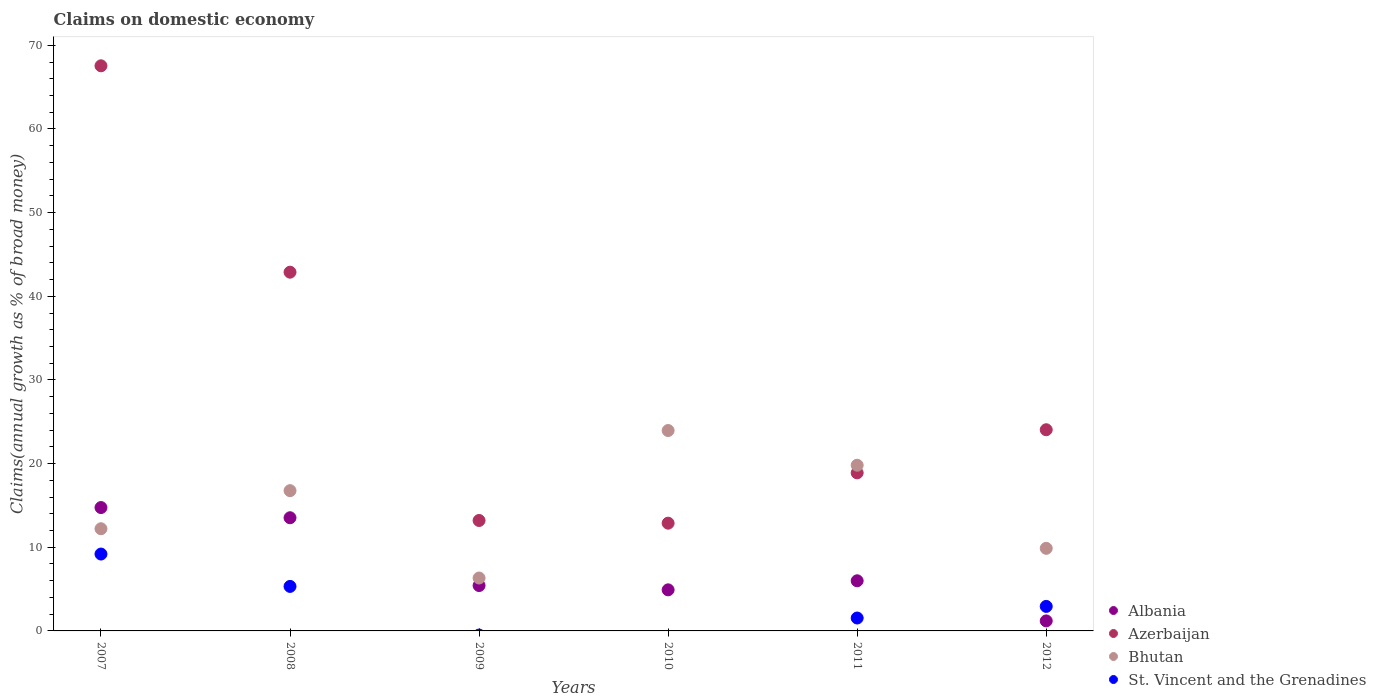How many different coloured dotlines are there?
Your response must be concise. 4. What is the percentage of broad money claimed on domestic economy in Azerbaijan in 2011?
Offer a terse response. 18.89. Across all years, what is the maximum percentage of broad money claimed on domestic economy in Albania?
Your answer should be compact. 14.75. Across all years, what is the minimum percentage of broad money claimed on domestic economy in Albania?
Ensure brevity in your answer.  1.2. What is the total percentage of broad money claimed on domestic economy in Bhutan in the graph?
Offer a terse response. 88.93. What is the difference between the percentage of broad money claimed on domestic economy in St. Vincent and the Grenadines in 2011 and that in 2012?
Offer a very short reply. -1.39. What is the difference between the percentage of broad money claimed on domestic economy in Albania in 2011 and the percentage of broad money claimed on domestic economy in Bhutan in 2009?
Your answer should be very brief. -0.33. What is the average percentage of broad money claimed on domestic economy in St. Vincent and the Grenadines per year?
Keep it short and to the point. 3.16. In the year 2011, what is the difference between the percentage of broad money claimed on domestic economy in St. Vincent and the Grenadines and percentage of broad money claimed on domestic economy in Albania?
Provide a succinct answer. -4.45. What is the ratio of the percentage of broad money claimed on domestic economy in Azerbaijan in 2007 to that in 2008?
Offer a very short reply. 1.58. What is the difference between the highest and the second highest percentage of broad money claimed on domestic economy in Albania?
Provide a short and direct response. 1.22. What is the difference between the highest and the lowest percentage of broad money claimed on domestic economy in St. Vincent and the Grenadines?
Ensure brevity in your answer.  9.19. Is the sum of the percentage of broad money claimed on domestic economy in Bhutan in 2010 and 2011 greater than the maximum percentage of broad money claimed on domestic economy in Azerbaijan across all years?
Ensure brevity in your answer.  No. Is it the case that in every year, the sum of the percentage of broad money claimed on domestic economy in St. Vincent and the Grenadines and percentage of broad money claimed on domestic economy in Azerbaijan  is greater than the percentage of broad money claimed on domestic economy in Bhutan?
Provide a succinct answer. No. Does the percentage of broad money claimed on domestic economy in St. Vincent and the Grenadines monotonically increase over the years?
Provide a short and direct response. No. Is the percentage of broad money claimed on domestic economy in Azerbaijan strictly less than the percentage of broad money claimed on domestic economy in St. Vincent and the Grenadines over the years?
Offer a terse response. No. How many dotlines are there?
Your answer should be compact. 4. How many years are there in the graph?
Keep it short and to the point. 6. What is the difference between two consecutive major ticks on the Y-axis?
Give a very brief answer. 10. Are the values on the major ticks of Y-axis written in scientific E-notation?
Provide a short and direct response. No. What is the title of the graph?
Your response must be concise. Claims on domestic economy. What is the label or title of the Y-axis?
Your answer should be very brief. Claims(annual growth as % of broad money). What is the Claims(annual growth as % of broad money) in Albania in 2007?
Provide a succinct answer. 14.75. What is the Claims(annual growth as % of broad money) in Azerbaijan in 2007?
Your answer should be compact. 67.55. What is the Claims(annual growth as % of broad money) of Bhutan in 2007?
Give a very brief answer. 12.21. What is the Claims(annual growth as % of broad money) of St. Vincent and the Grenadines in 2007?
Offer a very short reply. 9.19. What is the Claims(annual growth as % of broad money) in Albania in 2008?
Offer a terse response. 13.53. What is the Claims(annual growth as % of broad money) in Azerbaijan in 2008?
Your answer should be very brief. 42.88. What is the Claims(annual growth as % of broad money) of Bhutan in 2008?
Ensure brevity in your answer.  16.77. What is the Claims(annual growth as % of broad money) in St. Vincent and the Grenadines in 2008?
Give a very brief answer. 5.32. What is the Claims(annual growth as % of broad money) of Albania in 2009?
Your answer should be compact. 5.42. What is the Claims(annual growth as % of broad money) in Azerbaijan in 2009?
Provide a short and direct response. 13.2. What is the Claims(annual growth as % of broad money) of Bhutan in 2009?
Give a very brief answer. 6.32. What is the Claims(annual growth as % of broad money) of St. Vincent and the Grenadines in 2009?
Ensure brevity in your answer.  0. What is the Claims(annual growth as % of broad money) of Albania in 2010?
Provide a short and direct response. 4.91. What is the Claims(annual growth as % of broad money) in Azerbaijan in 2010?
Your answer should be very brief. 12.88. What is the Claims(annual growth as % of broad money) of Bhutan in 2010?
Give a very brief answer. 23.95. What is the Claims(annual growth as % of broad money) in St. Vincent and the Grenadines in 2010?
Give a very brief answer. 0. What is the Claims(annual growth as % of broad money) in Albania in 2011?
Make the answer very short. 5.99. What is the Claims(annual growth as % of broad money) of Azerbaijan in 2011?
Your answer should be very brief. 18.89. What is the Claims(annual growth as % of broad money) of Bhutan in 2011?
Offer a very short reply. 19.81. What is the Claims(annual growth as % of broad money) of St. Vincent and the Grenadines in 2011?
Provide a short and direct response. 1.54. What is the Claims(annual growth as % of broad money) of Albania in 2012?
Your response must be concise. 1.2. What is the Claims(annual growth as % of broad money) in Azerbaijan in 2012?
Offer a terse response. 24.05. What is the Claims(annual growth as % of broad money) in Bhutan in 2012?
Your answer should be very brief. 9.87. What is the Claims(annual growth as % of broad money) of St. Vincent and the Grenadines in 2012?
Make the answer very short. 2.93. Across all years, what is the maximum Claims(annual growth as % of broad money) of Albania?
Offer a terse response. 14.75. Across all years, what is the maximum Claims(annual growth as % of broad money) of Azerbaijan?
Provide a short and direct response. 67.55. Across all years, what is the maximum Claims(annual growth as % of broad money) of Bhutan?
Keep it short and to the point. 23.95. Across all years, what is the maximum Claims(annual growth as % of broad money) of St. Vincent and the Grenadines?
Give a very brief answer. 9.19. Across all years, what is the minimum Claims(annual growth as % of broad money) of Albania?
Offer a very short reply. 1.2. Across all years, what is the minimum Claims(annual growth as % of broad money) in Azerbaijan?
Offer a terse response. 12.88. Across all years, what is the minimum Claims(annual growth as % of broad money) of Bhutan?
Keep it short and to the point. 6.32. What is the total Claims(annual growth as % of broad money) of Albania in the graph?
Offer a very short reply. 45.8. What is the total Claims(annual growth as % of broad money) in Azerbaijan in the graph?
Offer a very short reply. 179.45. What is the total Claims(annual growth as % of broad money) of Bhutan in the graph?
Provide a succinct answer. 88.93. What is the total Claims(annual growth as % of broad money) in St. Vincent and the Grenadines in the graph?
Provide a succinct answer. 18.98. What is the difference between the Claims(annual growth as % of broad money) of Albania in 2007 and that in 2008?
Give a very brief answer. 1.22. What is the difference between the Claims(annual growth as % of broad money) in Azerbaijan in 2007 and that in 2008?
Offer a terse response. 24.67. What is the difference between the Claims(annual growth as % of broad money) in Bhutan in 2007 and that in 2008?
Keep it short and to the point. -4.55. What is the difference between the Claims(annual growth as % of broad money) of St. Vincent and the Grenadines in 2007 and that in 2008?
Provide a succinct answer. 3.87. What is the difference between the Claims(annual growth as % of broad money) in Albania in 2007 and that in 2009?
Give a very brief answer. 9.32. What is the difference between the Claims(annual growth as % of broad money) in Azerbaijan in 2007 and that in 2009?
Provide a succinct answer. 54.35. What is the difference between the Claims(annual growth as % of broad money) of Bhutan in 2007 and that in 2009?
Offer a very short reply. 5.89. What is the difference between the Claims(annual growth as % of broad money) of Albania in 2007 and that in 2010?
Ensure brevity in your answer.  9.84. What is the difference between the Claims(annual growth as % of broad money) of Azerbaijan in 2007 and that in 2010?
Make the answer very short. 54.67. What is the difference between the Claims(annual growth as % of broad money) in Bhutan in 2007 and that in 2010?
Your response must be concise. -11.74. What is the difference between the Claims(annual growth as % of broad money) of Albania in 2007 and that in 2011?
Ensure brevity in your answer.  8.75. What is the difference between the Claims(annual growth as % of broad money) in Azerbaijan in 2007 and that in 2011?
Provide a short and direct response. 48.66. What is the difference between the Claims(annual growth as % of broad money) in Bhutan in 2007 and that in 2011?
Make the answer very short. -7.59. What is the difference between the Claims(annual growth as % of broad money) in St. Vincent and the Grenadines in 2007 and that in 2011?
Offer a very short reply. 7.65. What is the difference between the Claims(annual growth as % of broad money) of Albania in 2007 and that in 2012?
Offer a very short reply. 13.55. What is the difference between the Claims(annual growth as % of broad money) of Azerbaijan in 2007 and that in 2012?
Give a very brief answer. 43.5. What is the difference between the Claims(annual growth as % of broad money) in Bhutan in 2007 and that in 2012?
Ensure brevity in your answer.  2.34. What is the difference between the Claims(annual growth as % of broad money) of St. Vincent and the Grenadines in 2007 and that in 2012?
Your response must be concise. 6.26. What is the difference between the Claims(annual growth as % of broad money) in Albania in 2008 and that in 2009?
Your answer should be very brief. 8.1. What is the difference between the Claims(annual growth as % of broad money) of Azerbaijan in 2008 and that in 2009?
Your answer should be compact. 29.68. What is the difference between the Claims(annual growth as % of broad money) in Bhutan in 2008 and that in 2009?
Keep it short and to the point. 10.44. What is the difference between the Claims(annual growth as % of broad money) in Albania in 2008 and that in 2010?
Offer a very short reply. 8.62. What is the difference between the Claims(annual growth as % of broad money) of Azerbaijan in 2008 and that in 2010?
Offer a very short reply. 30. What is the difference between the Claims(annual growth as % of broad money) of Bhutan in 2008 and that in 2010?
Give a very brief answer. -7.19. What is the difference between the Claims(annual growth as % of broad money) of Albania in 2008 and that in 2011?
Ensure brevity in your answer.  7.54. What is the difference between the Claims(annual growth as % of broad money) in Azerbaijan in 2008 and that in 2011?
Give a very brief answer. 23.99. What is the difference between the Claims(annual growth as % of broad money) of Bhutan in 2008 and that in 2011?
Your answer should be very brief. -3.04. What is the difference between the Claims(annual growth as % of broad money) of St. Vincent and the Grenadines in 2008 and that in 2011?
Keep it short and to the point. 3.78. What is the difference between the Claims(annual growth as % of broad money) of Albania in 2008 and that in 2012?
Offer a very short reply. 12.33. What is the difference between the Claims(annual growth as % of broad money) in Azerbaijan in 2008 and that in 2012?
Give a very brief answer. 18.83. What is the difference between the Claims(annual growth as % of broad money) of Bhutan in 2008 and that in 2012?
Provide a short and direct response. 6.89. What is the difference between the Claims(annual growth as % of broad money) in St. Vincent and the Grenadines in 2008 and that in 2012?
Provide a short and direct response. 2.39. What is the difference between the Claims(annual growth as % of broad money) of Albania in 2009 and that in 2010?
Your answer should be very brief. 0.51. What is the difference between the Claims(annual growth as % of broad money) in Azerbaijan in 2009 and that in 2010?
Provide a succinct answer. 0.32. What is the difference between the Claims(annual growth as % of broad money) in Bhutan in 2009 and that in 2010?
Make the answer very short. -17.63. What is the difference between the Claims(annual growth as % of broad money) of Albania in 2009 and that in 2011?
Make the answer very short. -0.57. What is the difference between the Claims(annual growth as % of broad money) of Azerbaijan in 2009 and that in 2011?
Give a very brief answer. -5.69. What is the difference between the Claims(annual growth as % of broad money) in Bhutan in 2009 and that in 2011?
Your response must be concise. -13.48. What is the difference between the Claims(annual growth as % of broad money) of Albania in 2009 and that in 2012?
Give a very brief answer. 4.23. What is the difference between the Claims(annual growth as % of broad money) of Azerbaijan in 2009 and that in 2012?
Your answer should be very brief. -10.85. What is the difference between the Claims(annual growth as % of broad money) in Bhutan in 2009 and that in 2012?
Your response must be concise. -3.55. What is the difference between the Claims(annual growth as % of broad money) in Albania in 2010 and that in 2011?
Provide a short and direct response. -1.08. What is the difference between the Claims(annual growth as % of broad money) in Azerbaijan in 2010 and that in 2011?
Your answer should be compact. -6.01. What is the difference between the Claims(annual growth as % of broad money) in Bhutan in 2010 and that in 2011?
Provide a succinct answer. 4.15. What is the difference between the Claims(annual growth as % of broad money) in Albania in 2010 and that in 2012?
Give a very brief answer. 3.71. What is the difference between the Claims(annual growth as % of broad money) of Azerbaijan in 2010 and that in 2012?
Make the answer very short. -11.17. What is the difference between the Claims(annual growth as % of broad money) in Bhutan in 2010 and that in 2012?
Keep it short and to the point. 14.08. What is the difference between the Claims(annual growth as % of broad money) of Albania in 2011 and that in 2012?
Provide a short and direct response. 4.79. What is the difference between the Claims(annual growth as % of broad money) in Azerbaijan in 2011 and that in 2012?
Make the answer very short. -5.16. What is the difference between the Claims(annual growth as % of broad money) of Bhutan in 2011 and that in 2012?
Provide a succinct answer. 9.93. What is the difference between the Claims(annual growth as % of broad money) in St. Vincent and the Grenadines in 2011 and that in 2012?
Offer a terse response. -1.39. What is the difference between the Claims(annual growth as % of broad money) in Albania in 2007 and the Claims(annual growth as % of broad money) in Azerbaijan in 2008?
Your answer should be compact. -28.13. What is the difference between the Claims(annual growth as % of broad money) of Albania in 2007 and the Claims(annual growth as % of broad money) of Bhutan in 2008?
Provide a short and direct response. -2.02. What is the difference between the Claims(annual growth as % of broad money) in Albania in 2007 and the Claims(annual growth as % of broad money) in St. Vincent and the Grenadines in 2008?
Provide a short and direct response. 9.43. What is the difference between the Claims(annual growth as % of broad money) of Azerbaijan in 2007 and the Claims(annual growth as % of broad money) of Bhutan in 2008?
Provide a succinct answer. 50.78. What is the difference between the Claims(annual growth as % of broad money) of Azerbaijan in 2007 and the Claims(annual growth as % of broad money) of St. Vincent and the Grenadines in 2008?
Your response must be concise. 62.23. What is the difference between the Claims(annual growth as % of broad money) in Bhutan in 2007 and the Claims(annual growth as % of broad money) in St. Vincent and the Grenadines in 2008?
Ensure brevity in your answer.  6.89. What is the difference between the Claims(annual growth as % of broad money) in Albania in 2007 and the Claims(annual growth as % of broad money) in Azerbaijan in 2009?
Give a very brief answer. 1.55. What is the difference between the Claims(annual growth as % of broad money) of Albania in 2007 and the Claims(annual growth as % of broad money) of Bhutan in 2009?
Your response must be concise. 8.42. What is the difference between the Claims(annual growth as % of broad money) in Azerbaijan in 2007 and the Claims(annual growth as % of broad money) in Bhutan in 2009?
Give a very brief answer. 61.23. What is the difference between the Claims(annual growth as % of broad money) in Albania in 2007 and the Claims(annual growth as % of broad money) in Azerbaijan in 2010?
Your answer should be very brief. 1.87. What is the difference between the Claims(annual growth as % of broad money) of Albania in 2007 and the Claims(annual growth as % of broad money) of Bhutan in 2010?
Give a very brief answer. -9.21. What is the difference between the Claims(annual growth as % of broad money) of Azerbaijan in 2007 and the Claims(annual growth as % of broad money) of Bhutan in 2010?
Offer a very short reply. 43.6. What is the difference between the Claims(annual growth as % of broad money) of Albania in 2007 and the Claims(annual growth as % of broad money) of Azerbaijan in 2011?
Offer a very short reply. -4.15. What is the difference between the Claims(annual growth as % of broad money) of Albania in 2007 and the Claims(annual growth as % of broad money) of Bhutan in 2011?
Your response must be concise. -5.06. What is the difference between the Claims(annual growth as % of broad money) in Albania in 2007 and the Claims(annual growth as % of broad money) in St. Vincent and the Grenadines in 2011?
Offer a very short reply. 13.2. What is the difference between the Claims(annual growth as % of broad money) of Azerbaijan in 2007 and the Claims(annual growth as % of broad money) of Bhutan in 2011?
Offer a very short reply. 47.74. What is the difference between the Claims(annual growth as % of broad money) in Azerbaijan in 2007 and the Claims(annual growth as % of broad money) in St. Vincent and the Grenadines in 2011?
Your answer should be very brief. 66.01. What is the difference between the Claims(annual growth as % of broad money) of Bhutan in 2007 and the Claims(annual growth as % of broad money) of St. Vincent and the Grenadines in 2011?
Your response must be concise. 10.67. What is the difference between the Claims(annual growth as % of broad money) in Albania in 2007 and the Claims(annual growth as % of broad money) in Azerbaijan in 2012?
Make the answer very short. -9.3. What is the difference between the Claims(annual growth as % of broad money) in Albania in 2007 and the Claims(annual growth as % of broad money) in Bhutan in 2012?
Your response must be concise. 4.87. What is the difference between the Claims(annual growth as % of broad money) of Albania in 2007 and the Claims(annual growth as % of broad money) of St. Vincent and the Grenadines in 2012?
Ensure brevity in your answer.  11.82. What is the difference between the Claims(annual growth as % of broad money) of Azerbaijan in 2007 and the Claims(annual growth as % of broad money) of Bhutan in 2012?
Make the answer very short. 57.68. What is the difference between the Claims(annual growth as % of broad money) of Azerbaijan in 2007 and the Claims(annual growth as % of broad money) of St. Vincent and the Grenadines in 2012?
Ensure brevity in your answer.  64.62. What is the difference between the Claims(annual growth as % of broad money) of Bhutan in 2007 and the Claims(annual growth as % of broad money) of St. Vincent and the Grenadines in 2012?
Keep it short and to the point. 9.28. What is the difference between the Claims(annual growth as % of broad money) in Albania in 2008 and the Claims(annual growth as % of broad money) in Azerbaijan in 2009?
Your answer should be compact. 0.33. What is the difference between the Claims(annual growth as % of broad money) of Albania in 2008 and the Claims(annual growth as % of broad money) of Bhutan in 2009?
Offer a very short reply. 7.2. What is the difference between the Claims(annual growth as % of broad money) of Azerbaijan in 2008 and the Claims(annual growth as % of broad money) of Bhutan in 2009?
Your response must be concise. 36.56. What is the difference between the Claims(annual growth as % of broad money) of Albania in 2008 and the Claims(annual growth as % of broad money) of Azerbaijan in 2010?
Make the answer very short. 0.65. What is the difference between the Claims(annual growth as % of broad money) in Albania in 2008 and the Claims(annual growth as % of broad money) in Bhutan in 2010?
Provide a succinct answer. -10.43. What is the difference between the Claims(annual growth as % of broad money) of Azerbaijan in 2008 and the Claims(annual growth as % of broad money) of Bhutan in 2010?
Your answer should be very brief. 18.93. What is the difference between the Claims(annual growth as % of broad money) in Albania in 2008 and the Claims(annual growth as % of broad money) in Azerbaijan in 2011?
Provide a short and direct response. -5.36. What is the difference between the Claims(annual growth as % of broad money) of Albania in 2008 and the Claims(annual growth as % of broad money) of Bhutan in 2011?
Offer a terse response. -6.28. What is the difference between the Claims(annual growth as % of broad money) of Albania in 2008 and the Claims(annual growth as % of broad money) of St. Vincent and the Grenadines in 2011?
Give a very brief answer. 11.99. What is the difference between the Claims(annual growth as % of broad money) of Azerbaijan in 2008 and the Claims(annual growth as % of broad money) of Bhutan in 2011?
Your answer should be very brief. 23.08. What is the difference between the Claims(annual growth as % of broad money) in Azerbaijan in 2008 and the Claims(annual growth as % of broad money) in St. Vincent and the Grenadines in 2011?
Your answer should be compact. 41.34. What is the difference between the Claims(annual growth as % of broad money) of Bhutan in 2008 and the Claims(annual growth as % of broad money) of St. Vincent and the Grenadines in 2011?
Your answer should be very brief. 15.22. What is the difference between the Claims(annual growth as % of broad money) of Albania in 2008 and the Claims(annual growth as % of broad money) of Azerbaijan in 2012?
Provide a short and direct response. -10.52. What is the difference between the Claims(annual growth as % of broad money) in Albania in 2008 and the Claims(annual growth as % of broad money) in Bhutan in 2012?
Provide a short and direct response. 3.66. What is the difference between the Claims(annual growth as % of broad money) in Albania in 2008 and the Claims(annual growth as % of broad money) in St. Vincent and the Grenadines in 2012?
Your answer should be very brief. 10.6. What is the difference between the Claims(annual growth as % of broad money) of Azerbaijan in 2008 and the Claims(annual growth as % of broad money) of Bhutan in 2012?
Provide a short and direct response. 33.01. What is the difference between the Claims(annual growth as % of broad money) of Azerbaijan in 2008 and the Claims(annual growth as % of broad money) of St. Vincent and the Grenadines in 2012?
Ensure brevity in your answer.  39.95. What is the difference between the Claims(annual growth as % of broad money) of Bhutan in 2008 and the Claims(annual growth as % of broad money) of St. Vincent and the Grenadines in 2012?
Offer a terse response. 13.84. What is the difference between the Claims(annual growth as % of broad money) of Albania in 2009 and the Claims(annual growth as % of broad money) of Azerbaijan in 2010?
Make the answer very short. -7.46. What is the difference between the Claims(annual growth as % of broad money) in Albania in 2009 and the Claims(annual growth as % of broad money) in Bhutan in 2010?
Ensure brevity in your answer.  -18.53. What is the difference between the Claims(annual growth as % of broad money) of Azerbaijan in 2009 and the Claims(annual growth as % of broad money) of Bhutan in 2010?
Make the answer very short. -10.75. What is the difference between the Claims(annual growth as % of broad money) of Albania in 2009 and the Claims(annual growth as % of broad money) of Azerbaijan in 2011?
Keep it short and to the point. -13.47. What is the difference between the Claims(annual growth as % of broad money) in Albania in 2009 and the Claims(annual growth as % of broad money) in Bhutan in 2011?
Provide a short and direct response. -14.38. What is the difference between the Claims(annual growth as % of broad money) in Albania in 2009 and the Claims(annual growth as % of broad money) in St. Vincent and the Grenadines in 2011?
Make the answer very short. 3.88. What is the difference between the Claims(annual growth as % of broad money) in Azerbaijan in 2009 and the Claims(annual growth as % of broad money) in Bhutan in 2011?
Offer a terse response. -6.61. What is the difference between the Claims(annual growth as % of broad money) in Azerbaijan in 2009 and the Claims(annual growth as % of broad money) in St. Vincent and the Grenadines in 2011?
Give a very brief answer. 11.66. What is the difference between the Claims(annual growth as % of broad money) of Bhutan in 2009 and the Claims(annual growth as % of broad money) of St. Vincent and the Grenadines in 2011?
Provide a short and direct response. 4.78. What is the difference between the Claims(annual growth as % of broad money) of Albania in 2009 and the Claims(annual growth as % of broad money) of Azerbaijan in 2012?
Provide a short and direct response. -18.62. What is the difference between the Claims(annual growth as % of broad money) in Albania in 2009 and the Claims(annual growth as % of broad money) in Bhutan in 2012?
Offer a very short reply. -4.45. What is the difference between the Claims(annual growth as % of broad money) in Albania in 2009 and the Claims(annual growth as % of broad money) in St. Vincent and the Grenadines in 2012?
Make the answer very short. 2.49. What is the difference between the Claims(annual growth as % of broad money) of Azerbaijan in 2009 and the Claims(annual growth as % of broad money) of Bhutan in 2012?
Your answer should be very brief. 3.33. What is the difference between the Claims(annual growth as % of broad money) in Azerbaijan in 2009 and the Claims(annual growth as % of broad money) in St. Vincent and the Grenadines in 2012?
Make the answer very short. 10.27. What is the difference between the Claims(annual growth as % of broad money) in Bhutan in 2009 and the Claims(annual growth as % of broad money) in St. Vincent and the Grenadines in 2012?
Give a very brief answer. 3.39. What is the difference between the Claims(annual growth as % of broad money) of Albania in 2010 and the Claims(annual growth as % of broad money) of Azerbaijan in 2011?
Offer a terse response. -13.98. What is the difference between the Claims(annual growth as % of broad money) in Albania in 2010 and the Claims(annual growth as % of broad money) in Bhutan in 2011?
Offer a very short reply. -14.89. What is the difference between the Claims(annual growth as % of broad money) in Albania in 2010 and the Claims(annual growth as % of broad money) in St. Vincent and the Grenadines in 2011?
Provide a short and direct response. 3.37. What is the difference between the Claims(annual growth as % of broad money) of Azerbaijan in 2010 and the Claims(annual growth as % of broad money) of Bhutan in 2011?
Provide a succinct answer. -6.93. What is the difference between the Claims(annual growth as % of broad money) of Azerbaijan in 2010 and the Claims(annual growth as % of broad money) of St. Vincent and the Grenadines in 2011?
Keep it short and to the point. 11.34. What is the difference between the Claims(annual growth as % of broad money) in Bhutan in 2010 and the Claims(annual growth as % of broad money) in St. Vincent and the Grenadines in 2011?
Make the answer very short. 22.41. What is the difference between the Claims(annual growth as % of broad money) in Albania in 2010 and the Claims(annual growth as % of broad money) in Azerbaijan in 2012?
Provide a succinct answer. -19.14. What is the difference between the Claims(annual growth as % of broad money) of Albania in 2010 and the Claims(annual growth as % of broad money) of Bhutan in 2012?
Provide a short and direct response. -4.96. What is the difference between the Claims(annual growth as % of broad money) in Albania in 2010 and the Claims(annual growth as % of broad money) in St. Vincent and the Grenadines in 2012?
Your response must be concise. 1.98. What is the difference between the Claims(annual growth as % of broad money) in Azerbaijan in 2010 and the Claims(annual growth as % of broad money) in Bhutan in 2012?
Offer a terse response. 3.01. What is the difference between the Claims(annual growth as % of broad money) in Azerbaijan in 2010 and the Claims(annual growth as % of broad money) in St. Vincent and the Grenadines in 2012?
Your answer should be compact. 9.95. What is the difference between the Claims(annual growth as % of broad money) in Bhutan in 2010 and the Claims(annual growth as % of broad money) in St. Vincent and the Grenadines in 2012?
Keep it short and to the point. 21.02. What is the difference between the Claims(annual growth as % of broad money) in Albania in 2011 and the Claims(annual growth as % of broad money) in Azerbaijan in 2012?
Ensure brevity in your answer.  -18.06. What is the difference between the Claims(annual growth as % of broad money) of Albania in 2011 and the Claims(annual growth as % of broad money) of Bhutan in 2012?
Make the answer very short. -3.88. What is the difference between the Claims(annual growth as % of broad money) of Albania in 2011 and the Claims(annual growth as % of broad money) of St. Vincent and the Grenadines in 2012?
Ensure brevity in your answer.  3.06. What is the difference between the Claims(annual growth as % of broad money) of Azerbaijan in 2011 and the Claims(annual growth as % of broad money) of Bhutan in 2012?
Your answer should be very brief. 9.02. What is the difference between the Claims(annual growth as % of broad money) of Azerbaijan in 2011 and the Claims(annual growth as % of broad money) of St. Vincent and the Grenadines in 2012?
Your response must be concise. 15.96. What is the difference between the Claims(annual growth as % of broad money) in Bhutan in 2011 and the Claims(annual growth as % of broad money) in St. Vincent and the Grenadines in 2012?
Keep it short and to the point. 16.88. What is the average Claims(annual growth as % of broad money) of Albania per year?
Offer a very short reply. 7.63. What is the average Claims(annual growth as % of broad money) in Azerbaijan per year?
Ensure brevity in your answer.  29.91. What is the average Claims(annual growth as % of broad money) of Bhutan per year?
Offer a terse response. 14.82. What is the average Claims(annual growth as % of broad money) in St. Vincent and the Grenadines per year?
Ensure brevity in your answer.  3.16. In the year 2007, what is the difference between the Claims(annual growth as % of broad money) of Albania and Claims(annual growth as % of broad money) of Azerbaijan?
Your answer should be very brief. -52.8. In the year 2007, what is the difference between the Claims(annual growth as % of broad money) in Albania and Claims(annual growth as % of broad money) in Bhutan?
Your response must be concise. 2.53. In the year 2007, what is the difference between the Claims(annual growth as % of broad money) in Albania and Claims(annual growth as % of broad money) in St. Vincent and the Grenadines?
Ensure brevity in your answer.  5.56. In the year 2007, what is the difference between the Claims(annual growth as % of broad money) of Azerbaijan and Claims(annual growth as % of broad money) of Bhutan?
Make the answer very short. 55.34. In the year 2007, what is the difference between the Claims(annual growth as % of broad money) in Azerbaijan and Claims(annual growth as % of broad money) in St. Vincent and the Grenadines?
Your answer should be compact. 58.36. In the year 2007, what is the difference between the Claims(annual growth as % of broad money) in Bhutan and Claims(annual growth as % of broad money) in St. Vincent and the Grenadines?
Provide a succinct answer. 3.03. In the year 2008, what is the difference between the Claims(annual growth as % of broad money) of Albania and Claims(annual growth as % of broad money) of Azerbaijan?
Ensure brevity in your answer.  -29.35. In the year 2008, what is the difference between the Claims(annual growth as % of broad money) of Albania and Claims(annual growth as % of broad money) of Bhutan?
Your response must be concise. -3.24. In the year 2008, what is the difference between the Claims(annual growth as % of broad money) of Albania and Claims(annual growth as % of broad money) of St. Vincent and the Grenadines?
Ensure brevity in your answer.  8.21. In the year 2008, what is the difference between the Claims(annual growth as % of broad money) in Azerbaijan and Claims(annual growth as % of broad money) in Bhutan?
Ensure brevity in your answer.  26.12. In the year 2008, what is the difference between the Claims(annual growth as % of broad money) in Azerbaijan and Claims(annual growth as % of broad money) in St. Vincent and the Grenadines?
Give a very brief answer. 37.56. In the year 2008, what is the difference between the Claims(annual growth as % of broad money) of Bhutan and Claims(annual growth as % of broad money) of St. Vincent and the Grenadines?
Offer a terse response. 11.44. In the year 2009, what is the difference between the Claims(annual growth as % of broad money) in Albania and Claims(annual growth as % of broad money) in Azerbaijan?
Your answer should be very brief. -7.78. In the year 2009, what is the difference between the Claims(annual growth as % of broad money) of Albania and Claims(annual growth as % of broad money) of Bhutan?
Your answer should be compact. -0.9. In the year 2009, what is the difference between the Claims(annual growth as % of broad money) in Azerbaijan and Claims(annual growth as % of broad money) in Bhutan?
Offer a terse response. 6.88. In the year 2010, what is the difference between the Claims(annual growth as % of broad money) in Albania and Claims(annual growth as % of broad money) in Azerbaijan?
Your answer should be very brief. -7.97. In the year 2010, what is the difference between the Claims(annual growth as % of broad money) in Albania and Claims(annual growth as % of broad money) in Bhutan?
Offer a terse response. -19.04. In the year 2010, what is the difference between the Claims(annual growth as % of broad money) in Azerbaijan and Claims(annual growth as % of broad money) in Bhutan?
Your answer should be very brief. -11.07. In the year 2011, what is the difference between the Claims(annual growth as % of broad money) in Albania and Claims(annual growth as % of broad money) in Azerbaijan?
Your response must be concise. -12.9. In the year 2011, what is the difference between the Claims(annual growth as % of broad money) in Albania and Claims(annual growth as % of broad money) in Bhutan?
Offer a very short reply. -13.81. In the year 2011, what is the difference between the Claims(annual growth as % of broad money) in Albania and Claims(annual growth as % of broad money) in St. Vincent and the Grenadines?
Your response must be concise. 4.45. In the year 2011, what is the difference between the Claims(annual growth as % of broad money) in Azerbaijan and Claims(annual growth as % of broad money) in Bhutan?
Offer a terse response. -0.91. In the year 2011, what is the difference between the Claims(annual growth as % of broad money) in Azerbaijan and Claims(annual growth as % of broad money) in St. Vincent and the Grenadines?
Offer a very short reply. 17.35. In the year 2011, what is the difference between the Claims(annual growth as % of broad money) in Bhutan and Claims(annual growth as % of broad money) in St. Vincent and the Grenadines?
Make the answer very short. 18.26. In the year 2012, what is the difference between the Claims(annual growth as % of broad money) of Albania and Claims(annual growth as % of broad money) of Azerbaijan?
Offer a terse response. -22.85. In the year 2012, what is the difference between the Claims(annual growth as % of broad money) in Albania and Claims(annual growth as % of broad money) in Bhutan?
Keep it short and to the point. -8.67. In the year 2012, what is the difference between the Claims(annual growth as % of broad money) in Albania and Claims(annual growth as % of broad money) in St. Vincent and the Grenadines?
Give a very brief answer. -1.73. In the year 2012, what is the difference between the Claims(annual growth as % of broad money) of Azerbaijan and Claims(annual growth as % of broad money) of Bhutan?
Provide a short and direct response. 14.18. In the year 2012, what is the difference between the Claims(annual growth as % of broad money) of Azerbaijan and Claims(annual growth as % of broad money) of St. Vincent and the Grenadines?
Your answer should be compact. 21.12. In the year 2012, what is the difference between the Claims(annual growth as % of broad money) of Bhutan and Claims(annual growth as % of broad money) of St. Vincent and the Grenadines?
Make the answer very short. 6.94. What is the ratio of the Claims(annual growth as % of broad money) of Albania in 2007 to that in 2008?
Make the answer very short. 1.09. What is the ratio of the Claims(annual growth as % of broad money) in Azerbaijan in 2007 to that in 2008?
Provide a succinct answer. 1.58. What is the ratio of the Claims(annual growth as % of broad money) in Bhutan in 2007 to that in 2008?
Ensure brevity in your answer.  0.73. What is the ratio of the Claims(annual growth as % of broad money) of St. Vincent and the Grenadines in 2007 to that in 2008?
Ensure brevity in your answer.  1.73. What is the ratio of the Claims(annual growth as % of broad money) of Albania in 2007 to that in 2009?
Keep it short and to the point. 2.72. What is the ratio of the Claims(annual growth as % of broad money) in Azerbaijan in 2007 to that in 2009?
Offer a very short reply. 5.12. What is the ratio of the Claims(annual growth as % of broad money) of Bhutan in 2007 to that in 2009?
Your answer should be very brief. 1.93. What is the ratio of the Claims(annual growth as % of broad money) in Albania in 2007 to that in 2010?
Offer a very short reply. 3. What is the ratio of the Claims(annual growth as % of broad money) in Azerbaijan in 2007 to that in 2010?
Offer a very short reply. 5.24. What is the ratio of the Claims(annual growth as % of broad money) in Bhutan in 2007 to that in 2010?
Your answer should be compact. 0.51. What is the ratio of the Claims(annual growth as % of broad money) of Albania in 2007 to that in 2011?
Your response must be concise. 2.46. What is the ratio of the Claims(annual growth as % of broad money) of Azerbaijan in 2007 to that in 2011?
Give a very brief answer. 3.58. What is the ratio of the Claims(annual growth as % of broad money) in Bhutan in 2007 to that in 2011?
Ensure brevity in your answer.  0.62. What is the ratio of the Claims(annual growth as % of broad money) in St. Vincent and the Grenadines in 2007 to that in 2011?
Give a very brief answer. 5.96. What is the ratio of the Claims(annual growth as % of broad money) in Albania in 2007 to that in 2012?
Make the answer very short. 12.3. What is the ratio of the Claims(annual growth as % of broad money) in Azerbaijan in 2007 to that in 2012?
Provide a succinct answer. 2.81. What is the ratio of the Claims(annual growth as % of broad money) of Bhutan in 2007 to that in 2012?
Keep it short and to the point. 1.24. What is the ratio of the Claims(annual growth as % of broad money) of St. Vincent and the Grenadines in 2007 to that in 2012?
Your answer should be compact. 3.14. What is the ratio of the Claims(annual growth as % of broad money) of Albania in 2008 to that in 2009?
Keep it short and to the point. 2.49. What is the ratio of the Claims(annual growth as % of broad money) in Azerbaijan in 2008 to that in 2009?
Provide a succinct answer. 3.25. What is the ratio of the Claims(annual growth as % of broad money) of Bhutan in 2008 to that in 2009?
Provide a short and direct response. 2.65. What is the ratio of the Claims(annual growth as % of broad money) in Albania in 2008 to that in 2010?
Your answer should be very brief. 2.75. What is the ratio of the Claims(annual growth as % of broad money) of Azerbaijan in 2008 to that in 2010?
Offer a very short reply. 3.33. What is the ratio of the Claims(annual growth as % of broad money) in Bhutan in 2008 to that in 2010?
Make the answer very short. 0.7. What is the ratio of the Claims(annual growth as % of broad money) in Albania in 2008 to that in 2011?
Provide a succinct answer. 2.26. What is the ratio of the Claims(annual growth as % of broad money) in Azerbaijan in 2008 to that in 2011?
Offer a very short reply. 2.27. What is the ratio of the Claims(annual growth as % of broad money) in Bhutan in 2008 to that in 2011?
Offer a very short reply. 0.85. What is the ratio of the Claims(annual growth as % of broad money) in St. Vincent and the Grenadines in 2008 to that in 2011?
Your answer should be compact. 3.45. What is the ratio of the Claims(annual growth as % of broad money) in Albania in 2008 to that in 2012?
Your response must be concise. 11.28. What is the ratio of the Claims(annual growth as % of broad money) of Azerbaijan in 2008 to that in 2012?
Keep it short and to the point. 1.78. What is the ratio of the Claims(annual growth as % of broad money) in Bhutan in 2008 to that in 2012?
Ensure brevity in your answer.  1.7. What is the ratio of the Claims(annual growth as % of broad money) of St. Vincent and the Grenadines in 2008 to that in 2012?
Offer a very short reply. 1.82. What is the ratio of the Claims(annual growth as % of broad money) in Albania in 2009 to that in 2010?
Your answer should be compact. 1.1. What is the ratio of the Claims(annual growth as % of broad money) in Azerbaijan in 2009 to that in 2010?
Your response must be concise. 1.02. What is the ratio of the Claims(annual growth as % of broad money) of Bhutan in 2009 to that in 2010?
Make the answer very short. 0.26. What is the ratio of the Claims(annual growth as % of broad money) in Albania in 2009 to that in 2011?
Provide a short and direct response. 0.91. What is the ratio of the Claims(annual growth as % of broad money) in Azerbaijan in 2009 to that in 2011?
Provide a succinct answer. 0.7. What is the ratio of the Claims(annual growth as % of broad money) in Bhutan in 2009 to that in 2011?
Your answer should be very brief. 0.32. What is the ratio of the Claims(annual growth as % of broad money) of Albania in 2009 to that in 2012?
Provide a short and direct response. 4.52. What is the ratio of the Claims(annual growth as % of broad money) of Azerbaijan in 2009 to that in 2012?
Provide a succinct answer. 0.55. What is the ratio of the Claims(annual growth as % of broad money) in Bhutan in 2009 to that in 2012?
Your answer should be very brief. 0.64. What is the ratio of the Claims(annual growth as % of broad money) of Albania in 2010 to that in 2011?
Give a very brief answer. 0.82. What is the ratio of the Claims(annual growth as % of broad money) in Azerbaijan in 2010 to that in 2011?
Give a very brief answer. 0.68. What is the ratio of the Claims(annual growth as % of broad money) in Bhutan in 2010 to that in 2011?
Provide a short and direct response. 1.21. What is the ratio of the Claims(annual growth as % of broad money) in Albania in 2010 to that in 2012?
Ensure brevity in your answer.  4.1. What is the ratio of the Claims(annual growth as % of broad money) in Azerbaijan in 2010 to that in 2012?
Your answer should be very brief. 0.54. What is the ratio of the Claims(annual growth as % of broad money) of Bhutan in 2010 to that in 2012?
Your answer should be compact. 2.43. What is the ratio of the Claims(annual growth as % of broad money) of Albania in 2011 to that in 2012?
Your answer should be compact. 5. What is the ratio of the Claims(annual growth as % of broad money) of Azerbaijan in 2011 to that in 2012?
Ensure brevity in your answer.  0.79. What is the ratio of the Claims(annual growth as % of broad money) in Bhutan in 2011 to that in 2012?
Offer a terse response. 2.01. What is the ratio of the Claims(annual growth as % of broad money) in St. Vincent and the Grenadines in 2011 to that in 2012?
Provide a succinct answer. 0.53. What is the difference between the highest and the second highest Claims(annual growth as % of broad money) in Albania?
Your answer should be very brief. 1.22. What is the difference between the highest and the second highest Claims(annual growth as % of broad money) of Azerbaijan?
Ensure brevity in your answer.  24.67. What is the difference between the highest and the second highest Claims(annual growth as % of broad money) of Bhutan?
Provide a succinct answer. 4.15. What is the difference between the highest and the second highest Claims(annual growth as % of broad money) of St. Vincent and the Grenadines?
Provide a succinct answer. 3.87. What is the difference between the highest and the lowest Claims(annual growth as % of broad money) of Albania?
Your response must be concise. 13.55. What is the difference between the highest and the lowest Claims(annual growth as % of broad money) in Azerbaijan?
Keep it short and to the point. 54.67. What is the difference between the highest and the lowest Claims(annual growth as % of broad money) in Bhutan?
Make the answer very short. 17.63. What is the difference between the highest and the lowest Claims(annual growth as % of broad money) of St. Vincent and the Grenadines?
Provide a short and direct response. 9.19. 